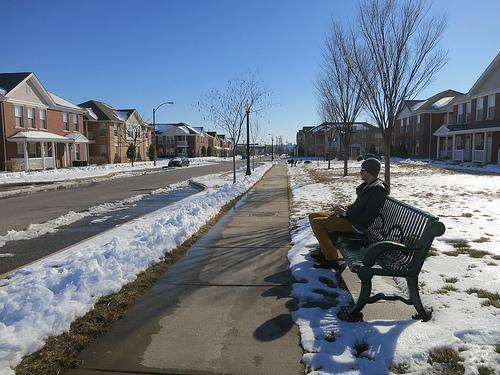How many people are there?
Give a very brief answer. 1. 